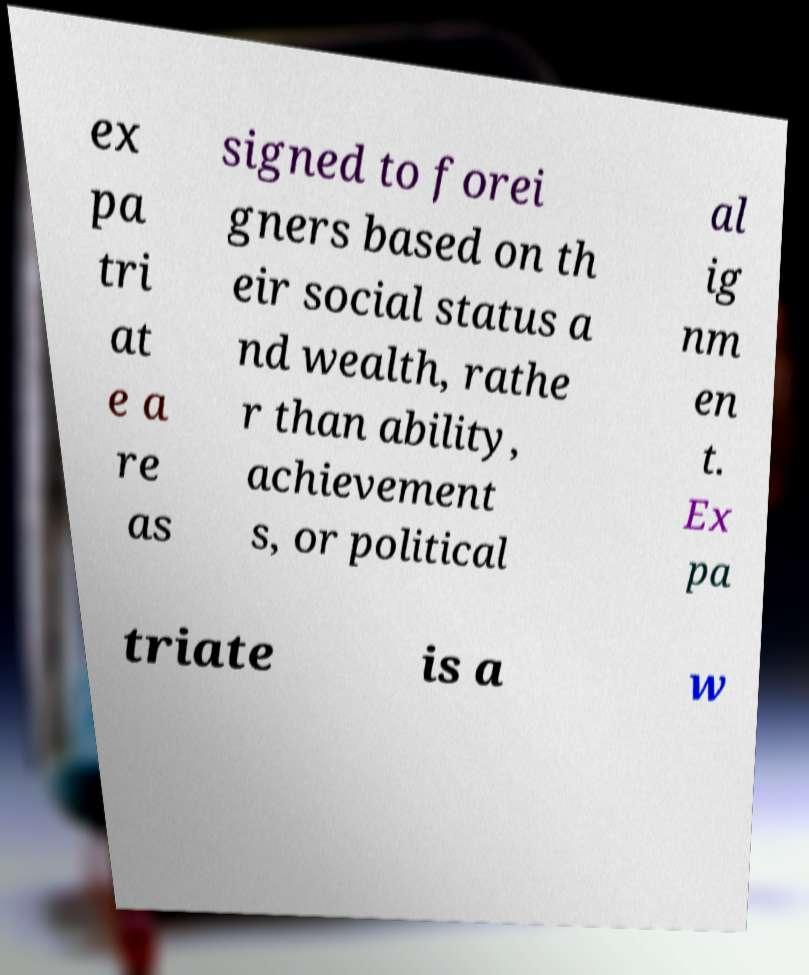For documentation purposes, I need the text within this image transcribed. Could you provide that? ex pa tri at e a re as signed to forei gners based on th eir social status a nd wealth, rathe r than ability, achievement s, or political al ig nm en t. Ex pa triate is a w 